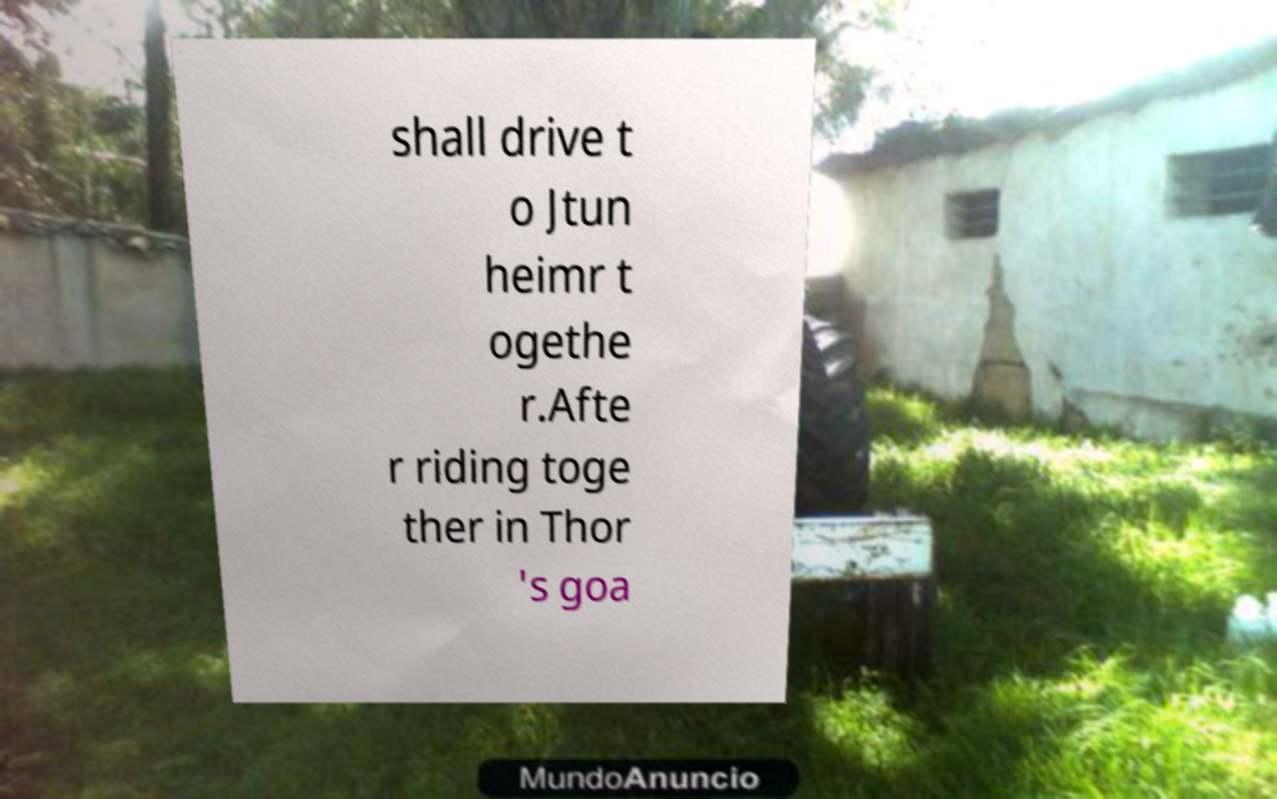Could you assist in decoding the text presented in this image and type it out clearly? shall drive t o Jtun heimr t ogethe r.Afte r riding toge ther in Thor 's goa 